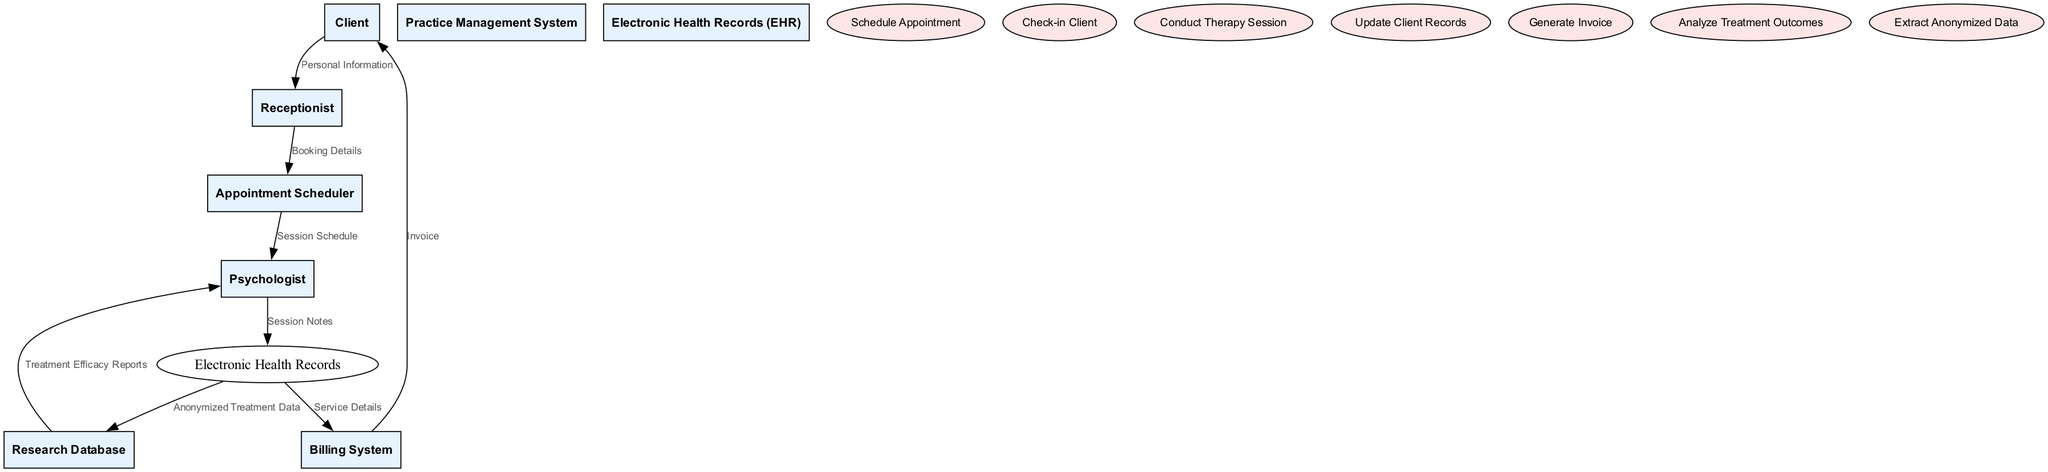What is the primary data a client provides to the receptionist? The client provides "Personal Information" to the receptionist as their primary data when they check in. This is the first interaction in the data flow.
Answer: Personal Information Who is responsible for checking in the client? The "Receptionist" is specifically noted in the diagram as the entity responsible for checking in clients, acting as the initial point of contact in the practice management system.
Answer: Receptionist What document does the billing system generate for the client? The billing system generates an "Invoice" which is sent to the client after processing the service details from the electronic health records.
Answer: Invoice How many main entities are there in the diagram? There are eight entities listed in the diagram, including Client, Receptionist, Psychologist, Practice Management System, Appointment Scheduler, Billing System, Electronic Health Records, and Research Database.
Answer: Eight What does the psychologist receive from the research database? The psychologist receives "Treatment Efficacy Reports" from the research database, which analyze the outcomes of treatments performed on clients based on anonymized data.
Answer: Treatment Efficacy Reports Which system receives the session notes from the psychologist? The "Electronic Health Records" system is the designated system that receives the session notes that the psychologist records after a therapy session.
Answer: Electronic Health Records What type of flow occurs from the electronic health records to the billing system? The flow from the "Electronic Health Records" to the "Billing System" is categorized as "Service Details," indicating that services provided during therapy sessions are communicated for billing.
Answer: Service Details Which two systems are involved in data flow regarding treatment outcomes? The "Electronic Health Records" and "Research Database" are the two systems involved in this data flow, with the EHR providing anonymized treatment data to the research database for analysis.
Answer: Electronic Health Records and Research Database What type of data does the receptionist send to the appointment scheduler? The receptionist sends "Booking Details" to the appointment scheduler, which includes information needed to schedule a client’s appointment with the psychologist.
Answer: Booking Details 